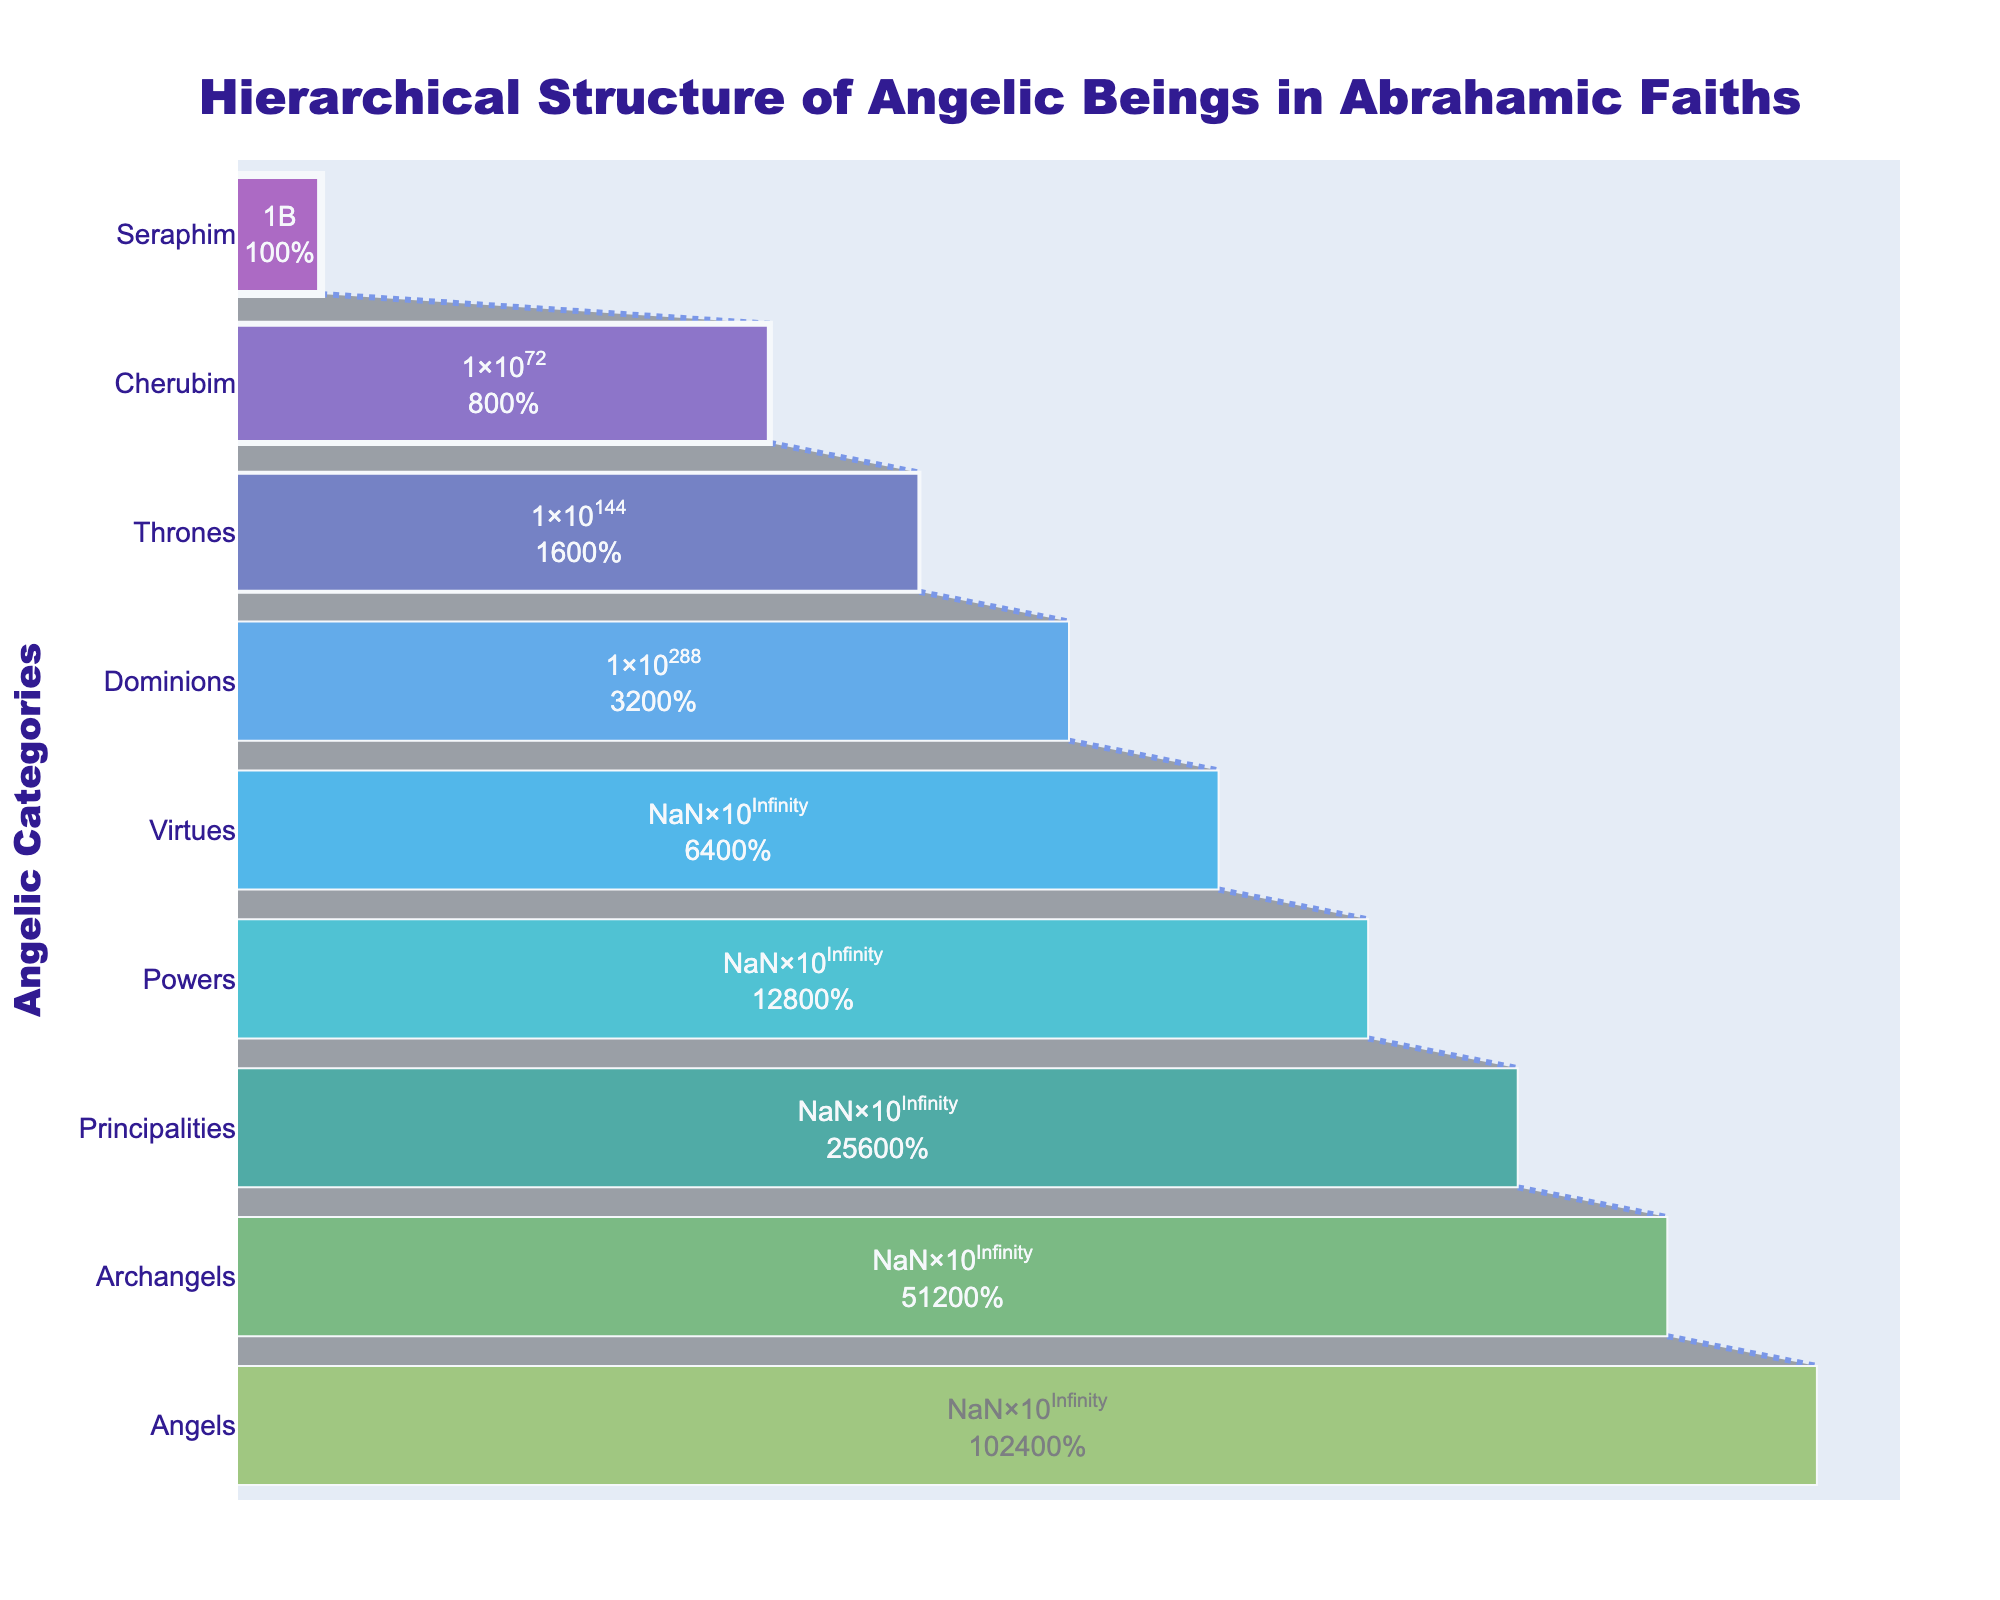What's the title of the funnel chart? The title is located at the top center of the chart and provides an overview of the figure's content. It reads "Hierarchical Structure of Angelic Beings in Abrahamic Faiths".
Answer: Hierarchical Structure of Angelic Beings in Abrahamic Faiths How many categories of angelic beings are shown in the chart? Each category on the y-axis represents a different type of angelic being. The figure lists these from Seraphim to Angels.
Answer: 9 Which category has the highest number of angels? By observing the x-axis values for each category, the category with the highest number is at the bottom, which is the "Angels" category.
Answer: Angels How many angels are in the Seraphim category? Referring to the chart, the number in the "Seraphim" category, located at the top of the funnel, is given.
Answer: 9 What is the total number of angels in the Dominions and Principalities categories combined? Locate the numbers for Dominions (288) and Principalities (2304), then sum them: 288 + 2304 = 2592.
Answer: 2592 How many more angels are there in the Archangels category compared to the Thrones category? Subtract the number of Thrones (144) from the number of Archangels (4608): 4608 - 144 = 4464.
Answer: 4464 Which category shows approximately twice the number of angels as the Virtues category? The number for Virtues is 576. The category showing twice that, approximately 1152, is the "Powers" category.
Answer: Powers What percentage of the total angel count do the Cherubim represent? The total number of angels is the sum of all categories: 9 + 72 + 144 + 288 + 576 + 1152 + 2304 + 4608 + 9216 = 17369. Cherubim number is 72. Calculate percentage: (72 / 17369) * 100 ≈ 0.41%.
Answer: 0.41% Which two categories have the smallest and largest number of angels, and what are their counts? By looking at the funnel chart, the smallest count is in the "Seraphim" category (9) and the largest in the "Angels" category (9216).
Answer: Seraphim: 9, Angels: 9216 What's the sum of all angels from the Virtues, Powers, and Principalities categories? Add the numbers for Virtues (576), Powers (1152), and Principalities (2304): 576 + 1152 + 2304 = 4032.
Answer: 4032 